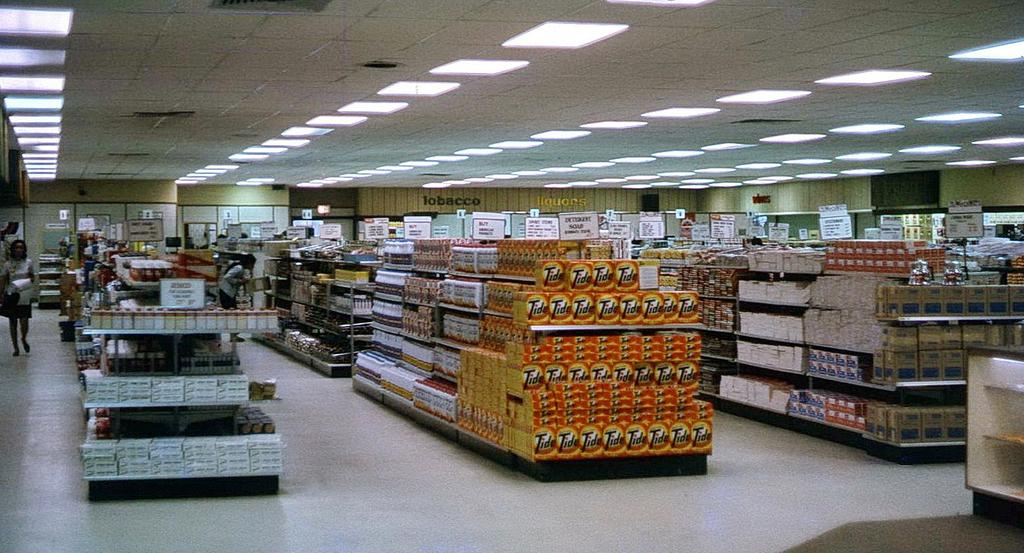What type of establishment is shown in the image? There is a supermarket in the image. How are the items organized inside the supermarket? The items are placed in racks inside the supermarket. What can be seen on the ceiling of the supermarket? There are lights on the ceiling of the supermarket. What are the people inside the supermarket doing? People are present on the floor of the supermarket, looking at the items. What type of cheese is being sold on the chair in the image? There is no chair or cheese present in the image; it only shows a supermarket with items placed in racks and people looking at them. 